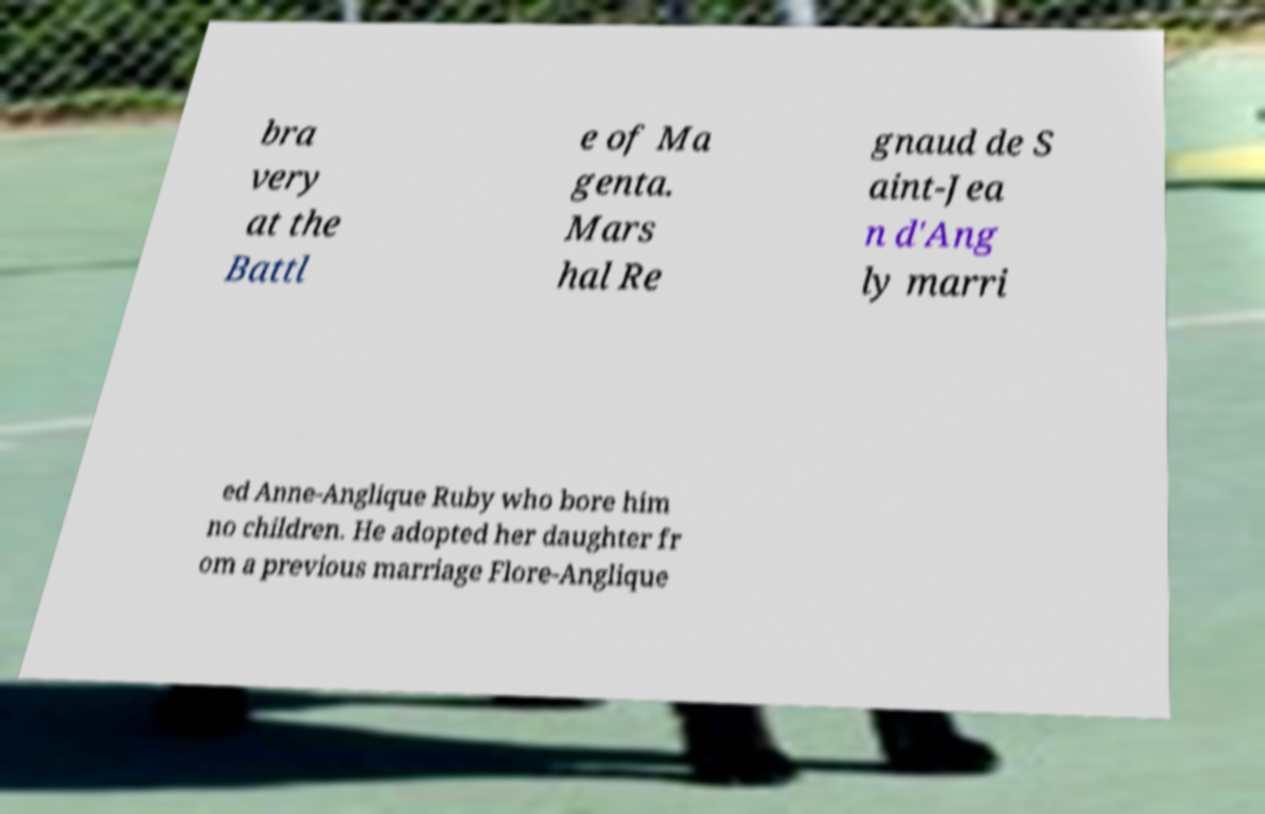Please identify and transcribe the text found in this image. bra very at the Battl e of Ma genta. Mars hal Re gnaud de S aint-Jea n d'Ang ly marri ed Anne-Anglique Ruby who bore him no children. He adopted her daughter fr om a previous marriage Flore-Anglique 